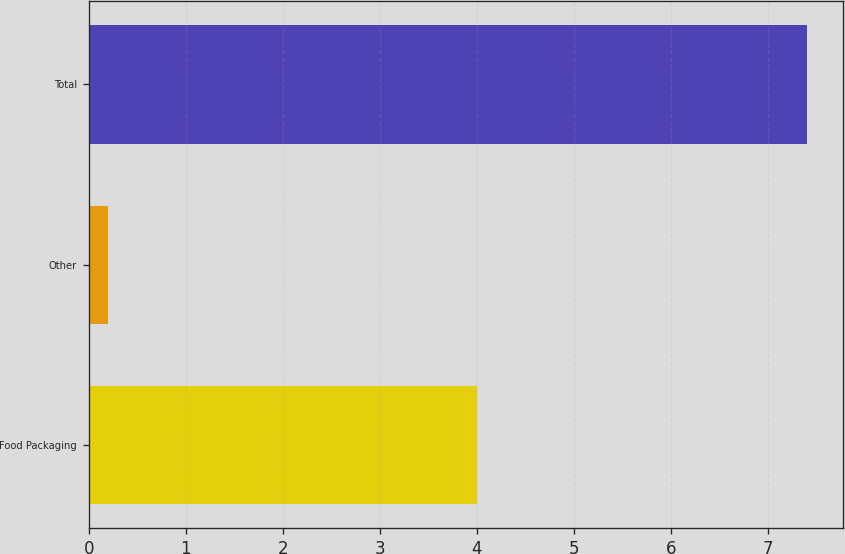<chart> <loc_0><loc_0><loc_500><loc_500><bar_chart><fcel>Food Packaging<fcel>Other<fcel>Total<nl><fcel>4<fcel>0.2<fcel>7.4<nl></chart> 